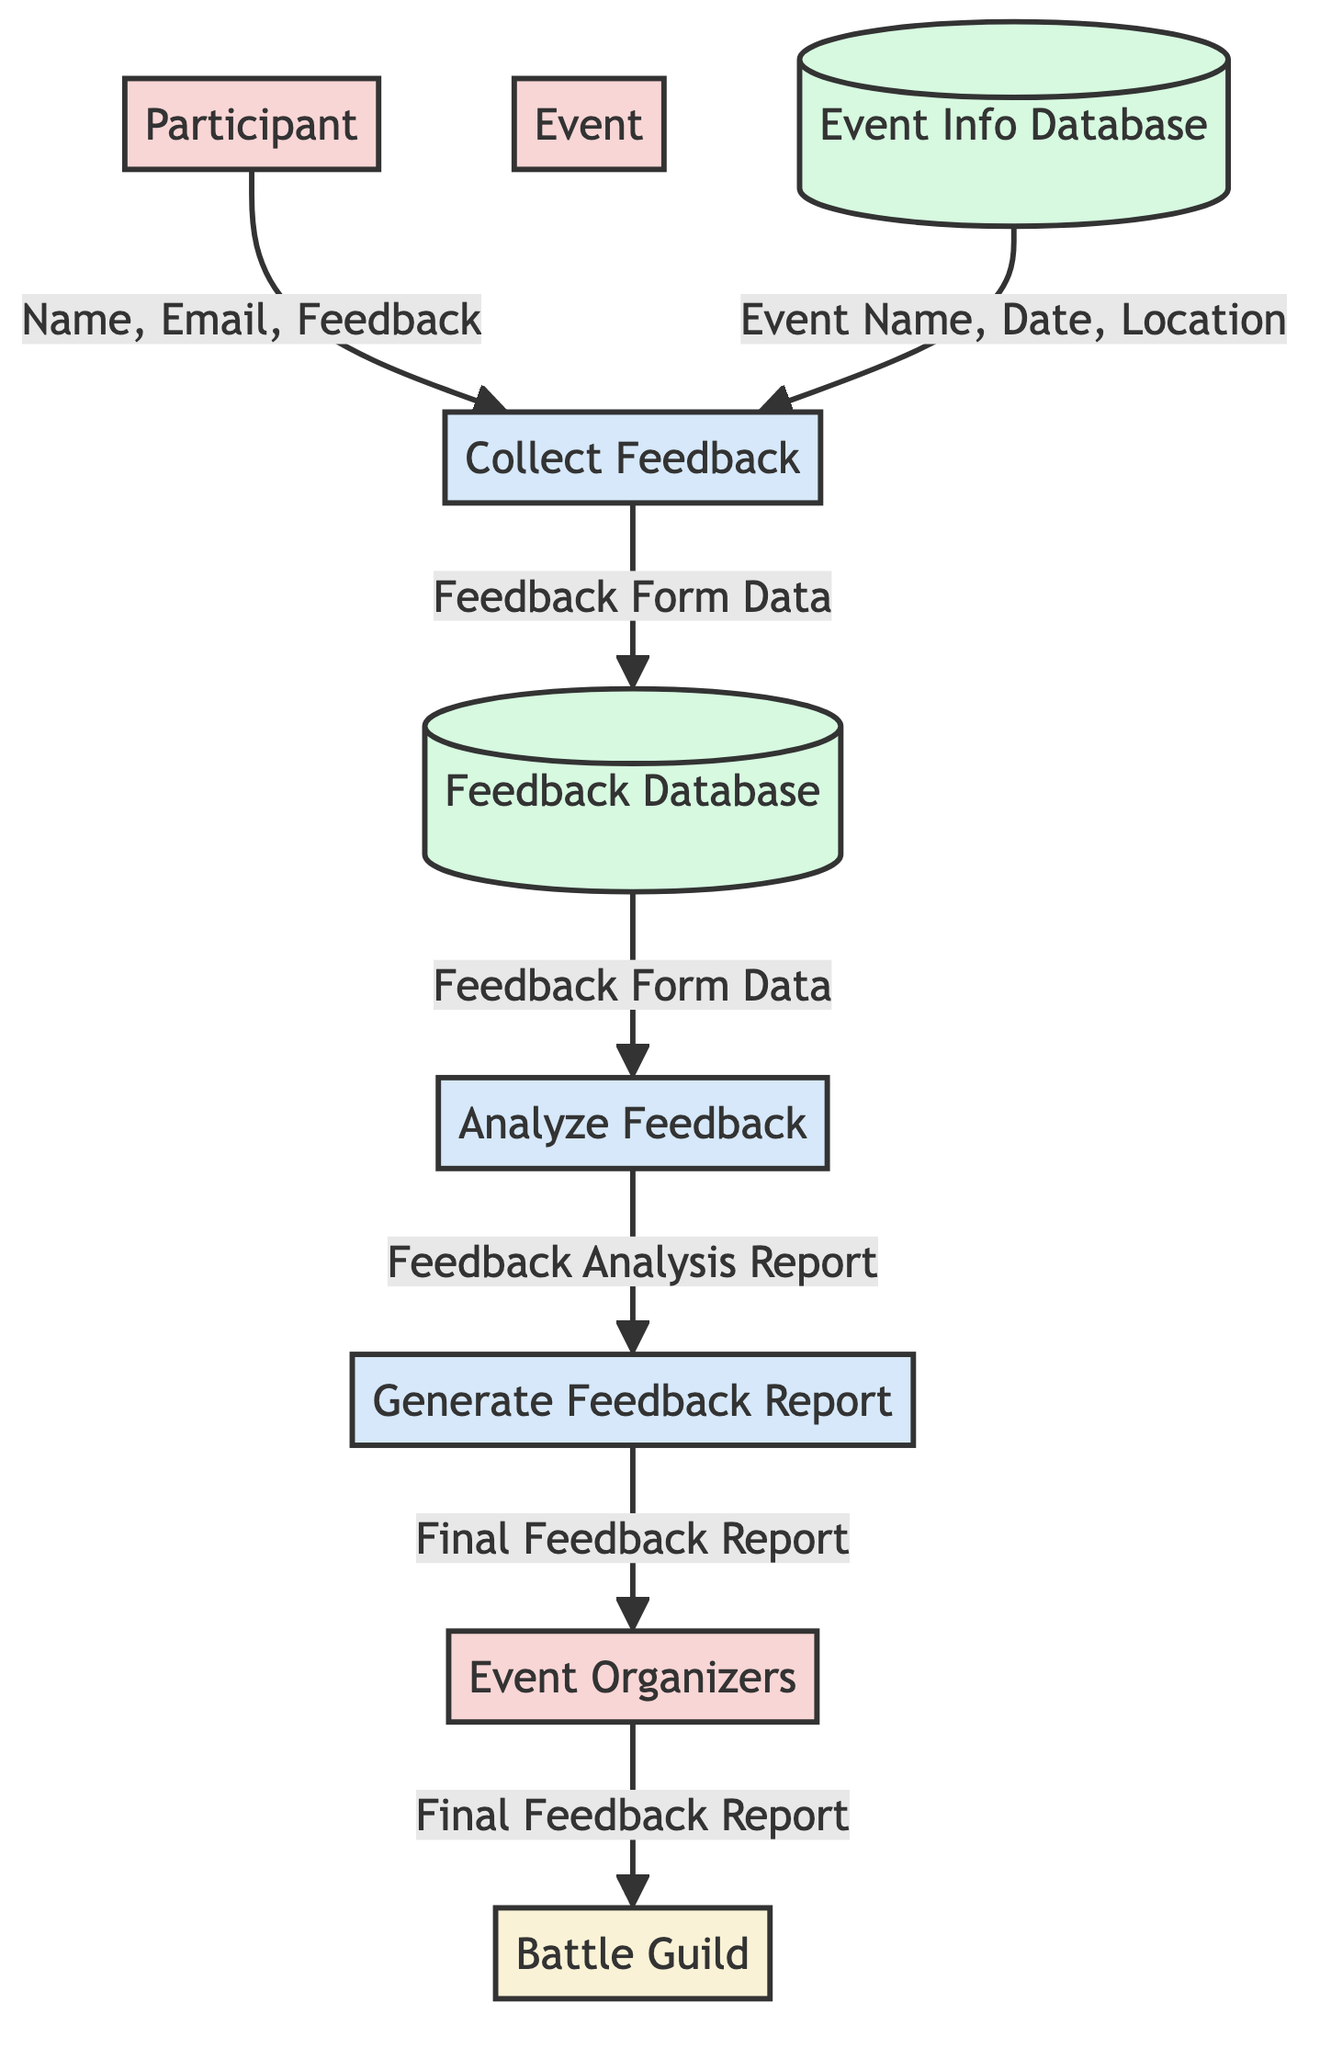What process collects feedback from participants? The process that collects feedback is named "Collect Feedback." It takes input from the Participant and Event entities, indicating that it's responsible for gathering feedback from participants regarding events.
Answer: Collect Feedback How many external entities are present in the diagram? There is only one external entity in the diagram, which is the "Battle Guild." It can be observed clearly since only one external entity is listed among the various components.
Answer: 1 What is the output of the "Analyze Feedback" process? The output of the "Analyze Feedback" process is the "Feedback Analysis Report." This can be found directly in the flow leading from the Analyze Feedback process to the Generate Feedback Report process.
Answer: Feedback Analysis Report What type of feedback data is stored in the Feedback Database? The type of feedback data stored in the Feedback Database is "Feedback Form Data." This is explicitly indicated in the diagram as the attribute associated with the Feedback Database data store.
Answer: Feedback Form Data What input does the "Generate Feedback Report" process require? The "Generate Feedback Report" process requires as input the "Feedback Analysis Report." This data flow can be traced from the Analyze Feedback process to the Generate Feedback Report process in the diagram.
Answer: Feedback Analysis Report What is the first step after collecting feedback from participants? The first step after collecting feedback from participants is to store the data in the "Feedback Database." This can be confirmed by noting that the Collect Feedback process outputs data directly to this data store.
Answer: Feedback Database Who receives the "Final Feedback Report"? The "Final Feedback Report" is received by "Event Organizers." This is indicated by the flow from the Generate Feedback Report process to the Event Organizers entity.
Answer: Event Organizers What data flows from the Event Info Database to the Collect Feedback process? The data that flows from the Event Info Database to the Collect Feedback process includes "Event Name, Date, Location." This can be seen in the arrows linking the Event Info Database to the Collect Feedback process, specifying the type of data shared.
Answer: Event Name, Date, Location Which process is directly connected to the Feedback Database? The "Analyze Feedback" process is directly connected to the Feedback Database, receiving data labeled as "Feedback Form Data" from it, as shown in the corresponding data flow.
Answer: Analyze Feedback 